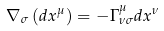<formula> <loc_0><loc_0><loc_500><loc_500>\nabla _ { \sigma } \left ( d x ^ { \mu } \right ) = - \Gamma _ { \nu \sigma } ^ { \mu } d x ^ { \nu }</formula> 